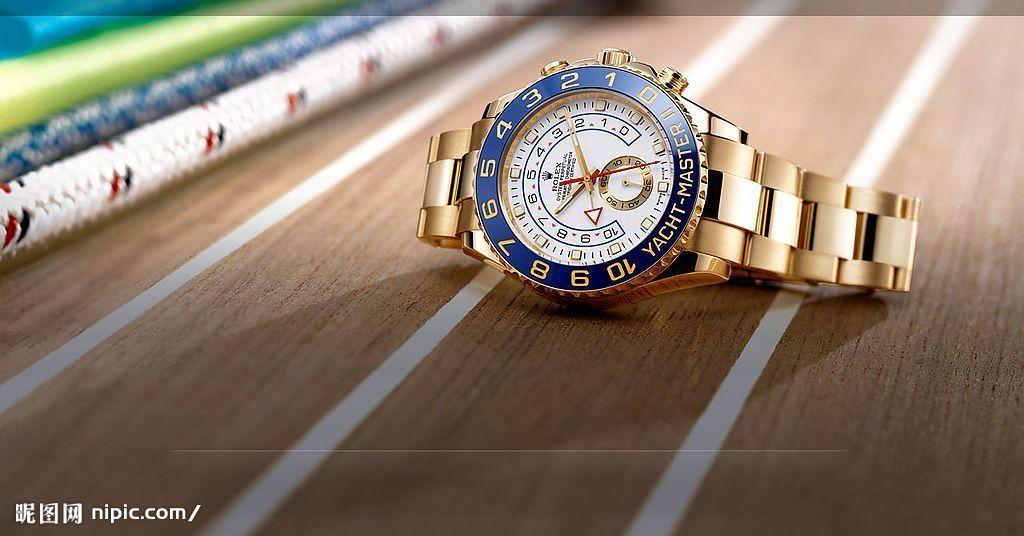<image>
Render a clear and concise summary of the photo. the word Yacht that is on a little watch 